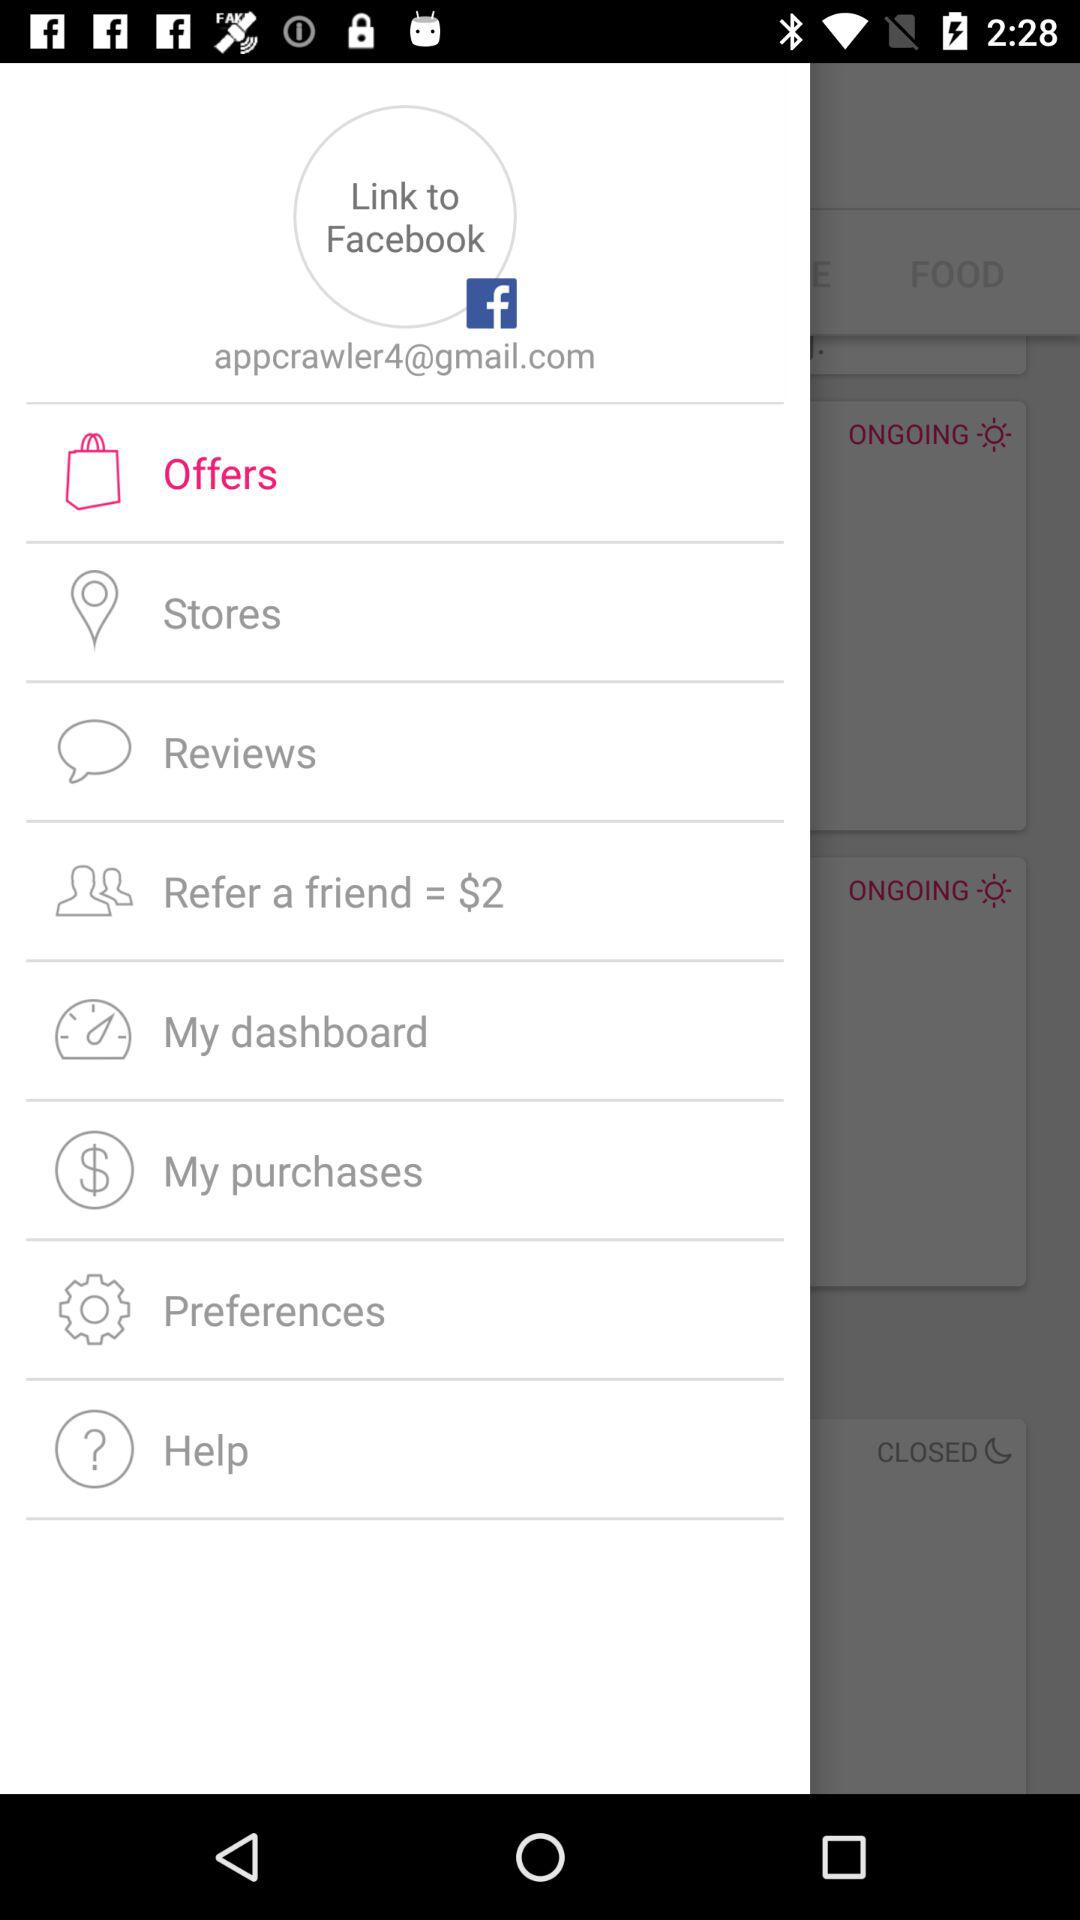How many dollars do we get for referring a friend? You get $2 for referring a friend. 